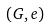Convert formula to latex. <formula><loc_0><loc_0><loc_500><loc_500>( G , e )</formula> 